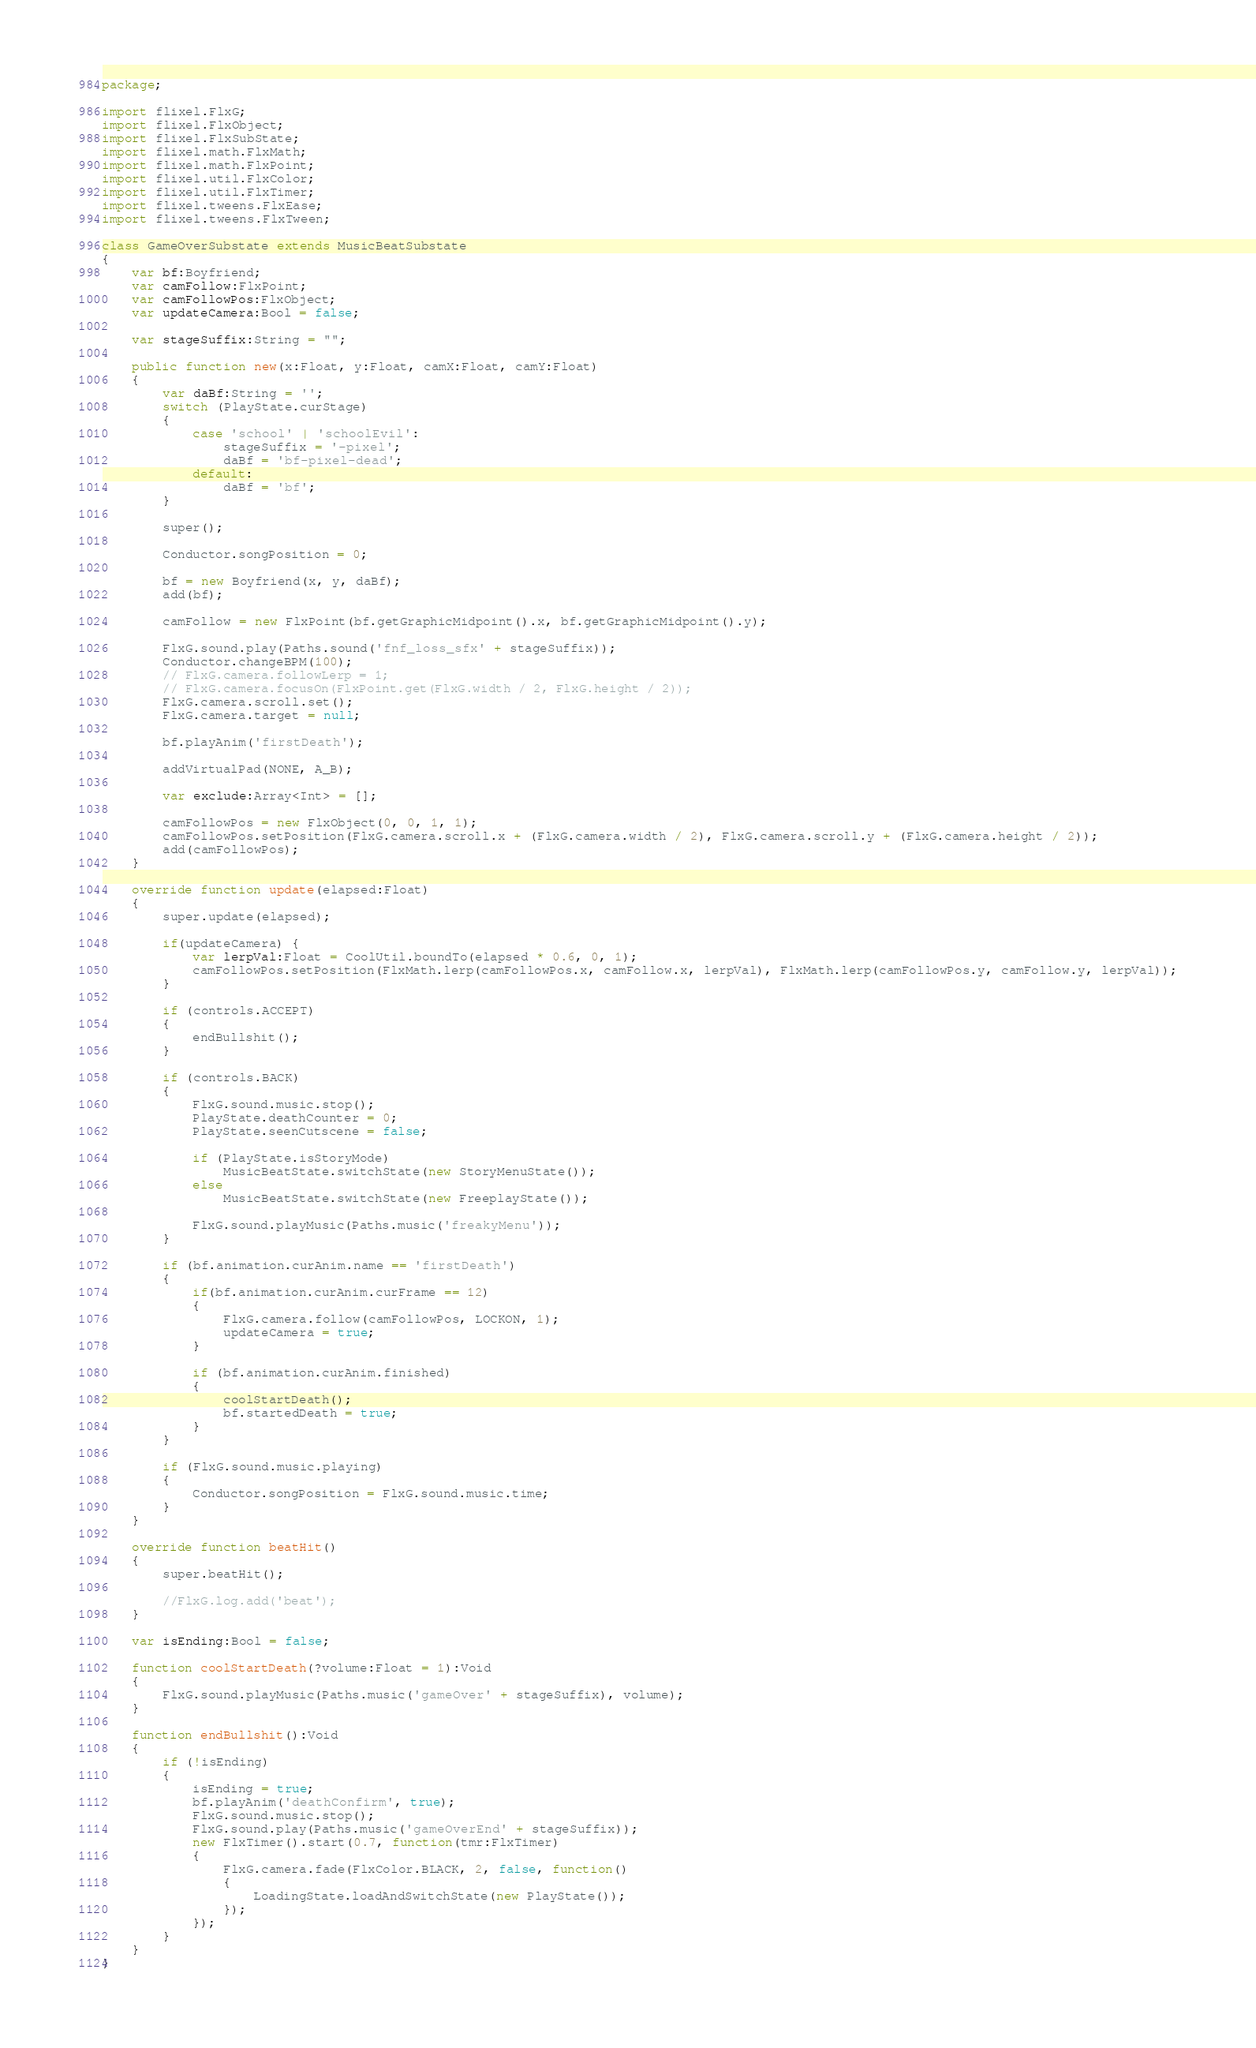<code> <loc_0><loc_0><loc_500><loc_500><_Haxe_>package;

import flixel.FlxG;
import flixel.FlxObject;
import flixel.FlxSubState;
import flixel.math.FlxMath;
import flixel.math.FlxPoint;
import flixel.util.FlxColor;
import flixel.util.FlxTimer;
import flixel.tweens.FlxEase;
import flixel.tweens.FlxTween;

class GameOverSubstate extends MusicBeatSubstate
{
	var bf:Boyfriend;
	var camFollow:FlxPoint;
	var camFollowPos:FlxObject;
	var updateCamera:Bool = false;

	var stageSuffix:String = "";

	public function new(x:Float, y:Float, camX:Float, camY:Float)
	{
		var daBf:String = '';
		switch (PlayState.curStage)
		{
			case 'school' | 'schoolEvil':
				stageSuffix = '-pixel';
				daBf = 'bf-pixel-dead';
			default:
				daBf = 'bf';
		}

		super();

		Conductor.songPosition = 0;

		bf = new Boyfriend(x, y, daBf);
		add(bf);

		camFollow = new FlxPoint(bf.getGraphicMidpoint().x, bf.getGraphicMidpoint().y);

		FlxG.sound.play(Paths.sound('fnf_loss_sfx' + stageSuffix));
		Conductor.changeBPM(100);
		// FlxG.camera.followLerp = 1;
		// FlxG.camera.focusOn(FlxPoint.get(FlxG.width / 2, FlxG.height / 2));
		FlxG.camera.scroll.set();
		FlxG.camera.target = null;

		bf.playAnim('firstDeath');

		addVirtualPad(NONE, A_B);

		var exclude:Array<Int> = [];

		camFollowPos = new FlxObject(0, 0, 1, 1);
		camFollowPos.setPosition(FlxG.camera.scroll.x + (FlxG.camera.width / 2), FlxG.camera.scroll.y + (FlxG.camera.height / 2));
		add(camFollowPos);
	}

	override function update(elapsed:Float)
	{
		super.update(elapsed);

		if(updateCamera) {
			var lerpVal:Float = CoolUtil.boundTo(elapsed * 0.6, 0, 1);
			camFollowPos.setPosition(FlxMath.lerp(camFollowPos.x, camFollow.x, lerpVal), FlxMath.lerp(camFollowPos.y, camFollow.y, lerpVal));
		}

		if (controls.ACCEPT)
		{
			endBullshit();
		}

		if (controls.BACK)
		{
			FlxG.sound.music.stop();
			PlayState.deathCounter = 0;
			PlayState.seenCutscene = false;

			if (PlayState.isStoryMode)
				MusicBeatState.switchState(new StoryMenuState());
			else
				MusicBeatState.switchState(new FreeplayState());

			FlxG.sound.playMusic(Paths.music('freakyMenu'));
		}

		if (bf.animation.curAnim.name == 'firstDeath')
		{
			if(bf.animation.curAnim.curFrame == 12)
			{
				FlxG.camera.follow(camFollowPos, LOCKON, 1);
				updateCamera = true;
			}

			if (bf.animation.curAnim.finished)
			{
				coolStartDeath();
				bf.startedDeath = true;
			}
		}

		if (FlxG.sound.music.playing)
		{
			Conductor.songPosition = FlxG.sound.music.time;
		}
	}

	override function beatHit()
	{
		super.beatHit();

		//FlxG.log.add('beat');
	}

	var isEnding:Bool = false;

	function coolStartDeath(?volume:Float = 1):Void
	{
		FlxG.sound.playMusic(Paths.music('gameOver' + stageSuffix), volume);
	}

	function endBullshit():Void
	{
		if (!isEnding)
		{
			isEnding = true;
			bf.playAnim('deathConfirm', true);
			FlxG.sound.music.stop();
			FlxG.sound.play(Paths.music('gameOverEnd' + stageSuffix));
			new FlxTimer().start(0.7, function(tmr:FlxTimer)
			{
				FlxG.camera.fade(FlxColor.BLACK, 2, false, function()
				{
					LoadingState.loadAndSwitchState(new PlayState());
				});
			});
		}
	}
}
</code> 